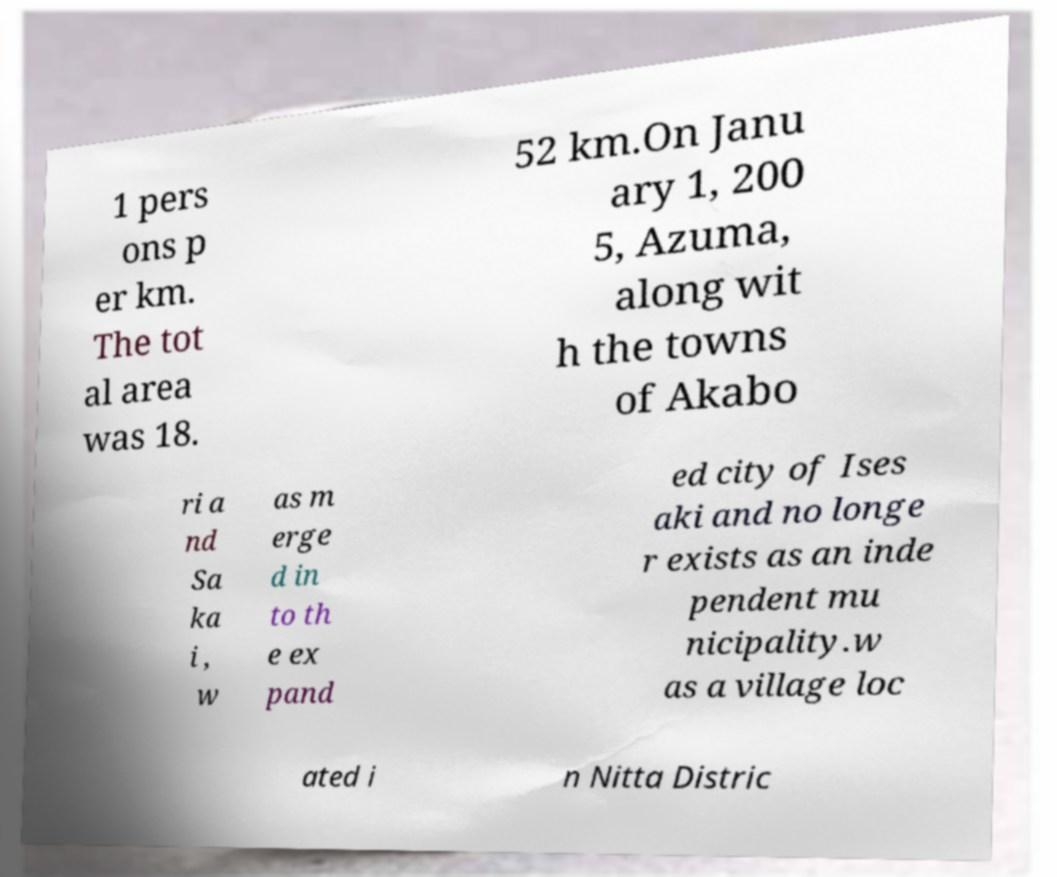Could you extract and type out the text from this image? 1 pers ons p er km. The tot al area was 18. 52 km.On Janu ary 1, 200 5, Azuma, along wit h the towns of Akabo ri a nd Sa ka i , w as m erge d in to th e ex pand ed city of Ises aki and no longe r exists as an inde pendent mu nicipality.w as a village loc ated i n Nitta Distric 